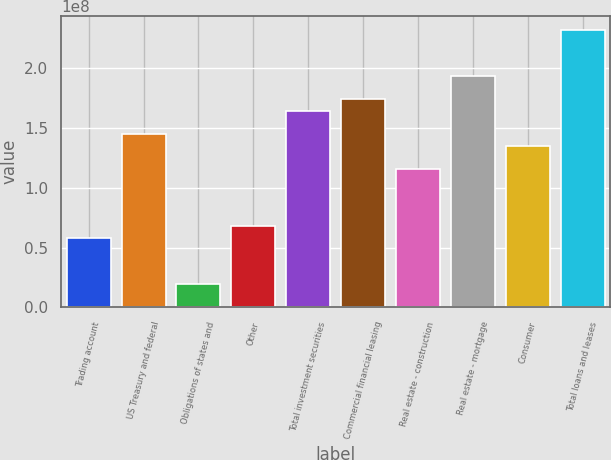<chart> <loc_0><loc_0><loc_500><loc_500><bar_chart><fcel>Trading account<fcel>US Treasury and federal<fcel>Obligations of states and<fcel>Other<fcel>Total investment securities<fcel>Commercial financial leasing<fcel>Real estate - construction<fcel>Real estate - mortgage<fcel>Consumer<fcel>Total loans and leases<nl><fcel>5.80253e+07<fcel>1.45011e+08<fcel>1.93651e+07<fcel>6.76904e+07<fcel>1.64341e+08<fcel>1.74006e+08<fcel>1.16016e+08<fcel>1.93336e+08<fcel>1.35346e+08<fcel>2.31996e+08<nl></chart> 